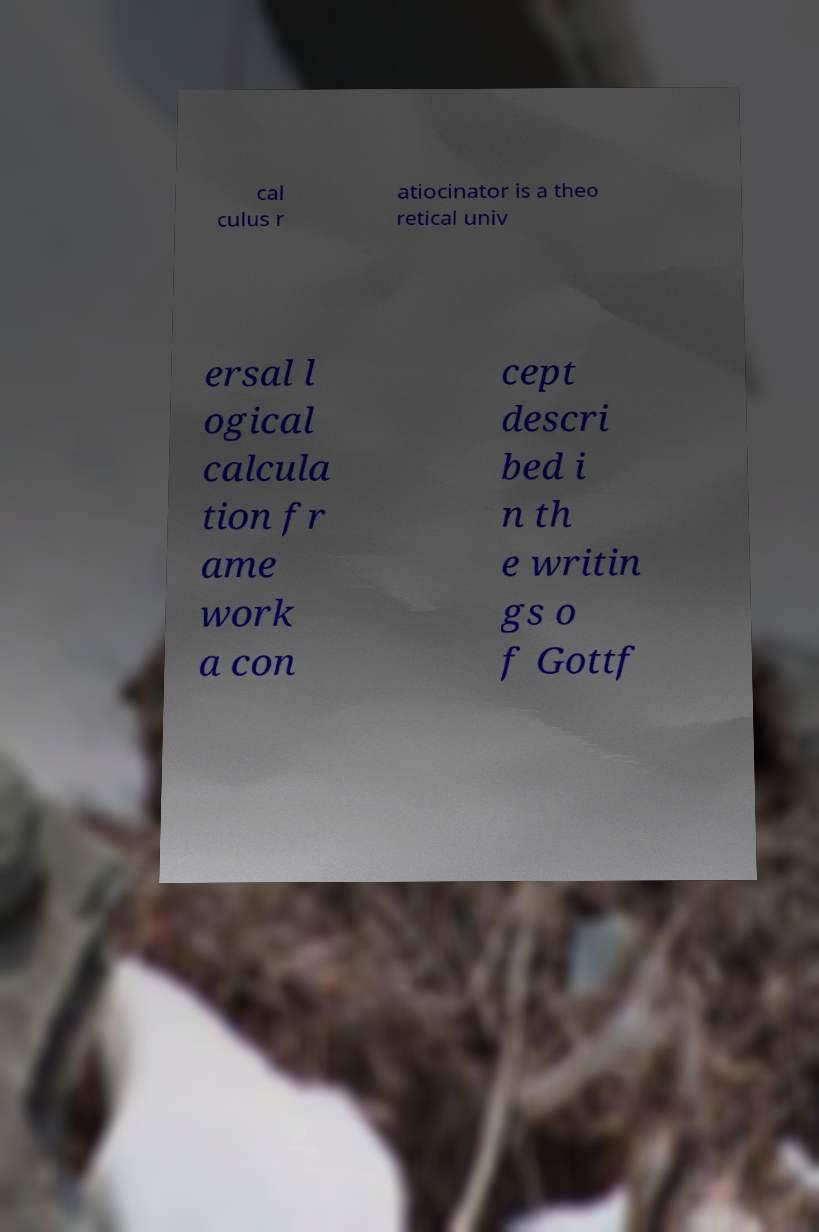I need the written content from this picture converted into text. Can you do that? cal culus r atiocinator is a theo retical univ ersal l ogical calcula tion fr ame work a con cept descri bed i n th e writin gs o f Gottf 